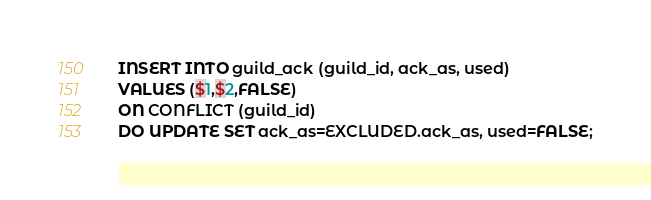<code> <loc_0><loc_0><loc_500><loc_500><_SQL_>INSERT INTO guild_ack (guild_id, ack_as, used)
VALUES ($1,$2,FALSE)
ON CONFLICT (guild_id)
DO UPDATE SET ack_as=EXCLUDED.ack_as, used=FALSE;</code> 